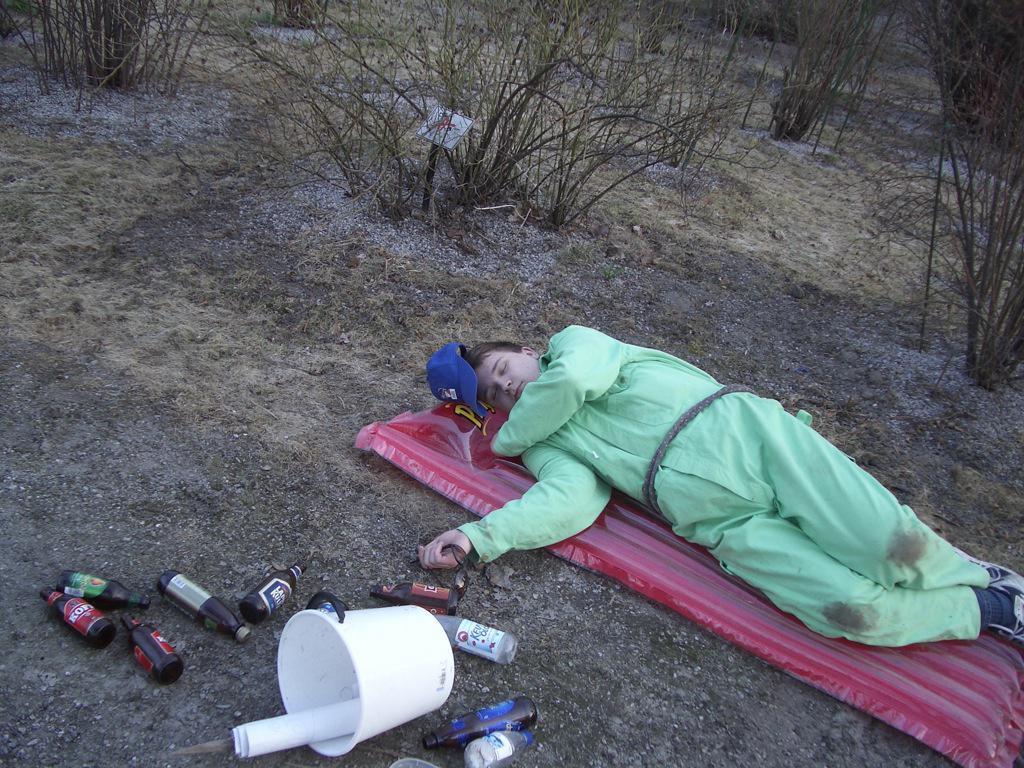Can you describe this image briefly? In the foreground of this image, there is a man lying on an inflatable bed on the ground along with a cap. At the bottom, there are few bottles and a chart in a bucket. At the top, there are trees without leaves. 